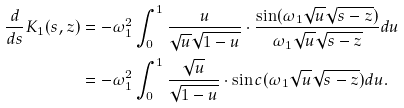<formula> <loc_0><loc_0><loc_500><loc_500>\frac { d } { d s } K _ { 1 } ( s , z ) & = - \omega _ { 1 } ^ { 2 } \int _ { 0 } ^ { 1 } \frac { u } { \sqrt { u } \sqrt { 1 - u } } \cdot \frac { \sin ( \omega _ { 1 } \sqrt { u } \sqrt { s - z } ) } { \omega _ { 1 } \sqrt { u } \sqrt { s - z } } d u \\ & = - \omega _ { 1 } ^ { 2 } \int _ { 0 } ^ { 1 } \frac { \sqrt { u } } { \sqrt { 1 - u } } \cdot \sin c ( \omega _ { 1 } \sqrt { u } \sqrt { s - z } ) d u .</formula> 